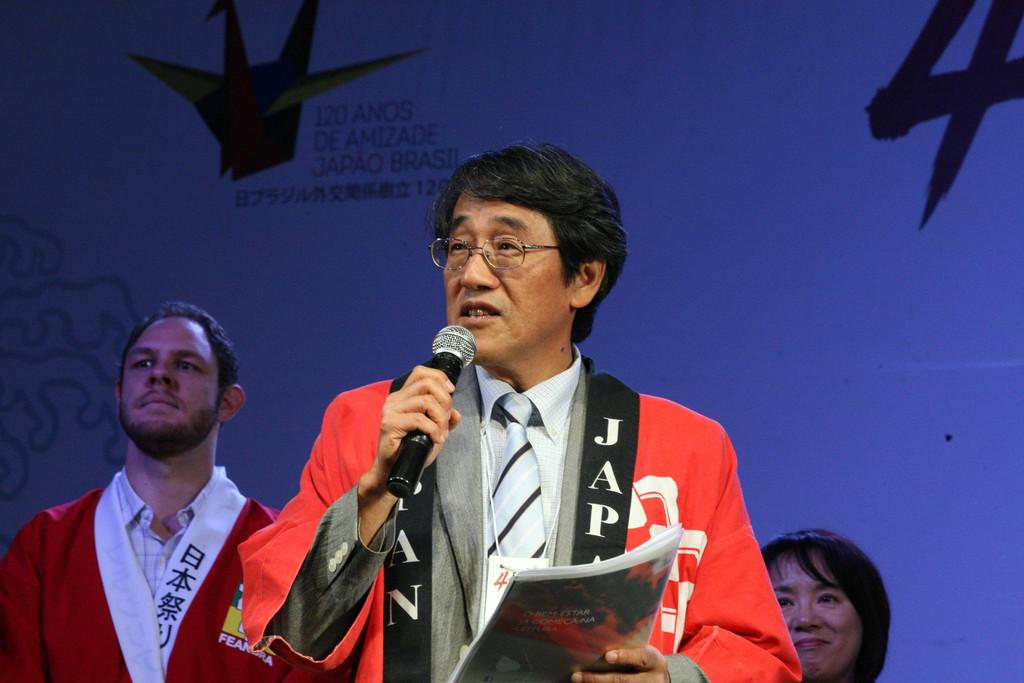<image>
Write a terse but informative summary of the picture. A man with a microphone, on his shirt it says Japan. 